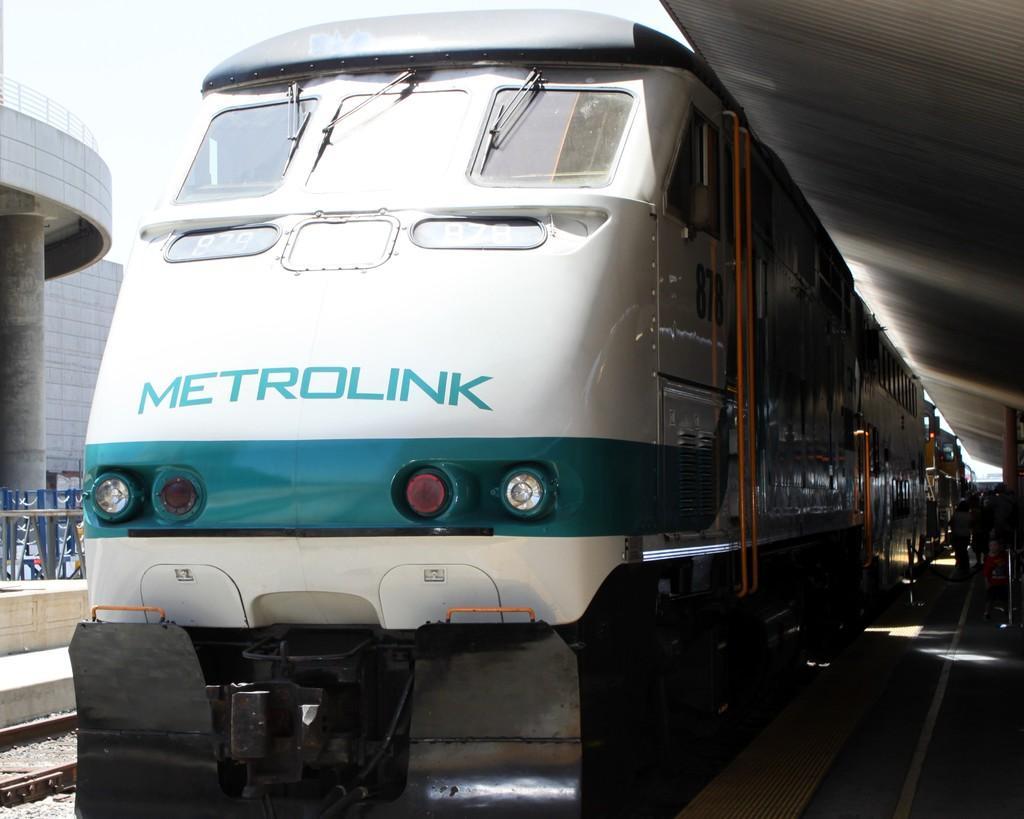How would you summarize this image in a sentence or two? In this image, we can see a train, we can see the railway platform, at the top we can see the sky. 